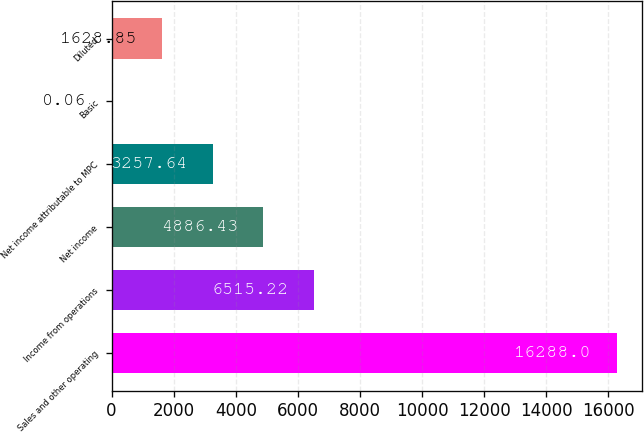<chart> <loc_0><loc_0><loc_500><loc_500><bar_chart><fcel>Sales and other operating<fcel>Income from operations<fcel>Net income<fcel>Net income attributable to MPC<fcel>Basic<fcel>Diluted<nl><fcel>16288<fcel>6515.22<fcel>4886.43<fcel>3257.64<fcel>0.06<fcel>1628.85<nl></chart> 